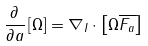<formula> <loc_0><loc_0><loc_500><loc_500>\frac { \partial } { \partial a } \left [ \Omega \right ] = \nabla _ { I } \cdot \left [ \Omega \overline { F _ { a } } \right ]</formula> 